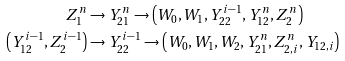Convert formula to latex. <formula><loc_0><loc_0><loc_500><loc_500>Z _ { 1 } ^ { n } & \rightarrow Y _ { 2 1 } ^ { n } \rightarrow \left ( W _ { 0 } , W _ { 1 } , Y _ { 2 2 } ^ { i - 1 } , Y _ { 1 2 } ^ { n } , Z _ { 2 } ^ { n } \right ) \\ \left ( Y _ { 1 2 } ^ { i - 1 } , Z _ { 2 } ^ { i - 1 } \right ) & \rightarrow Y _ { 2 2 } ^ { i - 1 } \rightarrow \left ( W _ { 0 } , W _ { 1 } , W _ { 2 } , Y _ { 2 1 } ^ { n } , Z _ { 2 , i } ^ { n } , Y _ { 1 2 , i } \right )</formula> 